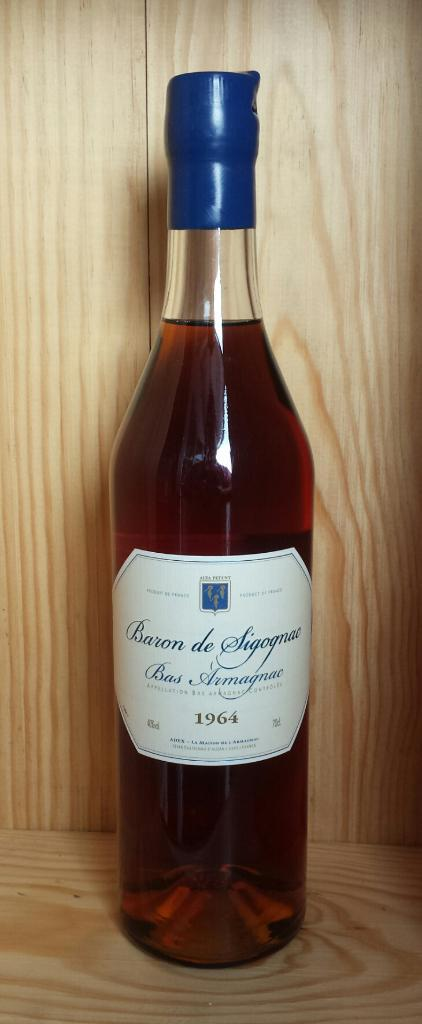<image>
Give a short and clear explanation of the subsequent image. A bottle with the year 1964 on it 